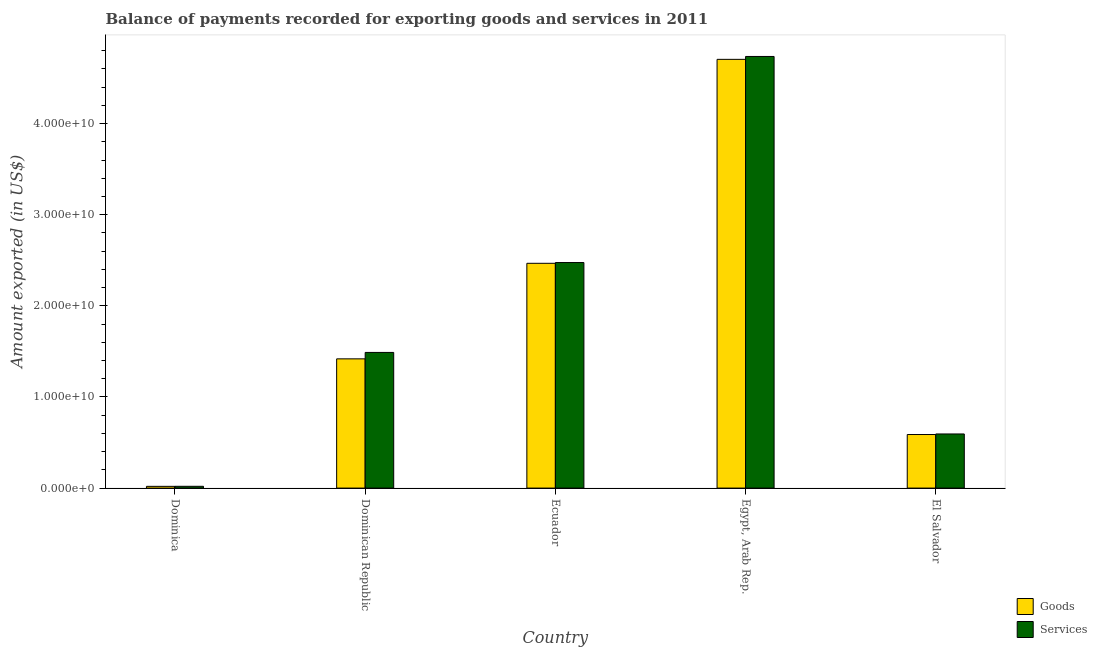How many different coloured bars are there?
Your answer should be very brief. 2. How many groups of bars are there?
Provide a short and direct response. 5. Are the number of bars on each tick of the X-axis equal?
Keep it short and to the point. Yes. What is the label of the 2nd group of bars from the left?
Your answer should be compact. Dominican Republic. In how many cases, is the number of bars for a given country not equal to the number of legend labels?
Make the answer very short. 0. What is the amount of goods exported in Egypt, Arab Rep.?
Your answer should be very brief. 4.71e+1. Across all countries, what is the maximum amount of services exported?
Give a very brief answer. 4.74e+1. Across all countries, what is the minimum amount of goods exported?
Make the answer very short. 1.91e+08. In which country was the amount of goods exported maximum?
Ensure brevity in your answer.  Egypt, Arab Rep. In which country was the amount of goods exported minimum?
Give a very brief answer. Dominica. What is the total amount of services exported in the graph?
Offer a very short reply. 9.32e+1. What is the difference between the amount of services exported in Dominica and that in Dominican Republic?
Keep it short and to the point. -1.47e+1. What is the difference between the amount of services exported in Ecuador and the amount of goods exported in Dominican Republic?
Ensure brevity in your answer.  1.06e+1. What is the average amount of services exported per country?
Your answer should be very brief. 1.86e+1. What is the difference between the amount of services exported and amount of goods exported in Dominica?
Your answer should be very brief. 4.93e+06. In how many countries, is the amount of goods exported greater than 12000000000 US$?
Provide a short and direct response. 3. What is the ratio of the amount of goods exported in Dominican Republic to that in Ecuador?
Your answer should be compact. 0.57. Is the difference between the amount of goods exported in Dominican Republic and Egypt, Arab Rep. greater than the difference between the amount of services exported in Dominican Republic and Egypt, Arab Rep.?
Your answer should be very brief. No. What is the difference between the highest and the second highest amount of goods exported?
Provide a short and direct response. 2.24e+1. What is the difference between the highest and the lowest amount of goods exported?
Offer a very short reply. 4.69e+1. In how many countries, is the amount of goods exported greater than the average amount of goods exported taken over all countries?
Provide a short and direct response. 2. Is the sum of the amount of services exported in Ecuador and Egypt, Arab Rep. greater than the maximum amount of goods exported across all countries?
Give a very brief answer. Yes. What does the 1st bar from the left in Dominican Republic represents?
Offer a terse response. Goods. What does the 2nd bar from the right in Dominica represents?
Your answer should be very brief. Goods. How many countries are there in the graph?
Your answer should be compact. 5. What is the difference between two consecutive major ticks on the Y-axis?
Provide a short and direct response. 1.00e+1. Does the graph contain any zero values?
Provide a short and direct response. No. What is the title of the graph?
Give a very brief answer. Balance of payments recorded for exporting goods and services in 2011. What is the label or title of the X-axis?
Make the answer very short. Country. What is the label or title of the Y-axis?
Provide a short and direct response. Amount exported (in US$). What is the Amount exported (in US$) in Goods in Dominica?
Your response must be concise. 1.91e+08. What is the Amount exported (in US$) of Services in Dominica?
Your answer should be very brief. 1.96e+08. What is the Amount exported (in US$) in Goods in Dominican Republic?
Give a very brief answer. 1.42e+1. What is the Amount exported (in US$) of Services in Dominican Republic?
Make the answer very short. 1.49e+1. What is the Amount exported (in US$) of Goods in Ecuador?
Your answer should be compact. 2.47e+1. What is the Amount exported (in US$) of Services in Ecuador?
Give a very brief answer. 2.48e+1. What is the Amount exported (in US$) of Goods in Egypt, Arab Rep.?
Your answer should be compact. 4.71e+1. What is the Amount exported (in US$) of Services in Egypt, Arab Rep.?
Your answer should be compact. 4.74e+1. What is the Amount exported (in US$) in Goods in El Salvador?
Provide a short and direct response. 5.88e+09. What is the Amount exported (in US$) in Services in El Salvador?
Provide a short and direct response. 5.94e+09. Across all countries, what is the maximum Amount exported (in US$) in Goods?
Your answer should be very brief. 4.71e+1. Across all countries, what is the maximum Amount exported (in US$) in Services?
Give a very brief answer. 4.74e+1. Across all countries, what is the minimum Amount exported (in US$) of Goods?
Make the answer very short. 1.91e+08. Across all countries, what is the minimum Amount exported (in US$) of Services?
Ensure brevity in your answer.  1.96e+08. What is the total Amount exported (in US$) of Goods in the graph?
Make the answer very short. 9.20e+1. What is the total Amount exported (in US$) of Services in the graph?
Offer a terse response. 9.32e+1. What is the difference between the Amount exported (in US$) of Goods in Dominica and that in Dominican Republic?
Provide a succinct answer. -1.40e+1. What is the difference between the Amount exported (in US$) in Services in Dominica and that in Dominican Republic?
Give a very brief answer. -1.47e+1. What is the difference between the Amount exported (in US$) in Goods in Dominica and that in Ecuador?
Your answer should be compact. -2.45e+1. What is the difference between the Amount exported (in US$) of Services in Dominica and that in Ecuador?
Ensure brevity in your answer.  -2.46e+1. What is the difference between the Amount exported (in US$) in Goods in Dominica and that in Egypt, Arab Rep.?
Provide a short and direct response. -4.69e+1. What is the difference between the Amount exported (in US$) of Services in Dominica and that in Egypt, Arab Rep.?
Ensure brevity in your answer.  -4.72e+1. What is the difference between the Amount exported (in US$) of Goods in Dominica and that in El Salvador?
Offer a very short reply. -5.69e+09. What is the difference between the Amount exported (in US$) of Services in Dominica and that in El Salvador?
Provide a short and direct response. -5.74e+09. What is the difference between the Amount exported (in US$) in Goods in Dominican Republic and that in Ecuador?
Your response must be concise. -1.05e+1. What is the difference between the Amount exported (in US$) of Services in Dominican Republic and that in Ecuador?
Your answer should be very brief. -9.87e+09. What is the difference between the Amount exported (in US$) in Goods in Dominican Republic and that in Egypt, Arab Rep.?
Your answer should be very brief. -3.29e+1. What is the difference between the Amount exported (in US$) in Services in Dominican Republic and that in Egypt, Arab Rep.?
Make the answer very short. -3.25e+1. What is the difference between the Amount exported (in US$) in Goods in Dominican Republic and that in El Salvador?
Your answer should be compact. 8.31e+09. What is the difference between the Amount exported (in US$) of Services in Dominican Republic and that in El Salvador?
Your response must be concise. 8.95e+09. What is the difference between the Amount exported (in US$) of Goods in Ecuador and that in Egypt, Arab Rep.?
Provide a succinct answer. -2.24e+1. What is the difference between the Amount exported (in US$) of Services in Ecuador and that in Egypt, Arab Rep.?
Your answer should be compact. -2.26e+1. What is the difference between the Amount exported (in US$) of Goods in Ecuador and that in El Salvador?
Give a very brief answer. 1.88e+1. What is the difference between the Amount exported (in US$) in Services in Ecuador and that in El Salvador?
Your response must be concise. 1.88e+1. What is the difference between the Amount exported (in US$) in Goods in Egypt, Arab Rep. and that in El Salvador?
Offer a very short reply. 4.12e+1. What is the difference between the Amount exported (in US$) in Services in Egypt, Arab Rep. and that in El Salvador?
Ensure brevity in your answer.  4.14e+1. What is the difference between the Amount exported (in US$) of Goods in Dominica and the Amount exported (in US$) of Services in Dominican Republic?
Your answer should be very brief. -1.47e+1. What is the difference between the Amount exported (in US$) in Goods in Dominica and the Amount exported (in US$) in Services in Ecuador?
Your response must be concise. -2.46e+1. What is the difference between the Amount exported (in US$) of Goods in Dominica and the Amount exported (in US$) of Services in Egypt, Arab Rep.?
Your answer should be compact. -4.72e+1. What is the difference between the Amount exported (in US$) of Goods in Dominica and the Amount exported (in US$) of Services in El Salvador?
Make the answer very short. -5.75e+09. What is the difference between the Amount exported (in US$) of Goods in Dominican Republic and the Amount exported (in US$) of Services in Ecuador?
Provide a succinct answer. -1.06e+1. What is the difference between the Amount exported (in US$) in Goods in Dominican Republic and the Amount exported (in US$) in Services in Egypt, Arab Rep.?
Make the answer very short. -3.32e+1. What is the difference between the Amount exported (in US$) of Goods in Dominican Republic and the Amount exported (in US$) of Services in El Salvador?
Ensure brevity in your answer.  8.24e+09. What is the difference between the Amount exported (in US$) of Goods in Ecuador and the Amount exported (in US$) of Services in Egypt, Arab Rep.?
Keep it short and to the point. -2.27e+1. What is the difference between the Amount exported (in US$) in Goods in Ecuador and the Amount exported (in US$) in Services in El Salvador?
Offer a terse response. 1.87e+1. What is the difference between the Amount exported (in US$) in Goods in Egypt, Arab Rep. and the Amount exported (in US$) in Services in El Salvador?
Ensure brevity in your answer.  4.11e+1. What is the average Amount exported (in US$) of Goods per country?
Make the answer very short. 1.84e+1. What is the average Amount exported (in US$) of Services per country?
Offer a terse response. 1.86e+1. What is the difference between the Amount exported (in US$) in Goods and Amount exported (in US$) in Services in Dominica?
Make the answer very short. -4.93e+06. What is the difference between the Amount exported (in US$) in Goods and Amount exported (in US$) in Services in Dominican Republic?
Ensure brevity in your answer.  -7.05e+08. What is the difference between the Amount exported (in US$) in Goods and Amount exported (in US$) in Services in Ecuador?
Your answer should be compact. -8.45e+07. What is the difference between the Amount exported (in US$) of Goods and Amount exported (in US$) of Services in Egypt, Arab Rep.?
Your response must be concise. -3.18e+08. What is the difference between the Amount exported (in US$) of Goods and Amount exported (in US$) of Services in El Salvador?
Your answer should be compact. -6.17e+07. What is the ratio of the Amount exported (in US$) in Goods in Dominica to that in Dominican Republic?
Provide a short and direct response. 0.01. What is the ratio of the Amount exported (in US$) of Services in Dominica to that in Dominican Republic?
Provide a short and direct response. 0.01. What is the ratio of the Amount exported (in US$) in Goods in Dominica to that in Ecuador?
Provide a short and direct response. 0.01. What is the ratio of the Amount exported (in US$) in Services in Dominica to that in Ecuador?
Your answer should be compact. 0.01. What is the ratio of the Amount exported (in US$) of Goods in Dominica to that in Egypt, Arab Rep.?
Offer a very short reply. 0. What is the ratio of the Amount exported (in US$) in Services in Dominica to that in Egypt, Arab Rep.?
Offer a very short reply. 0. What is the ratio of the Amount exported (in US$) in Goods in Dominica to that in El Salvador?
Offer a very short reply. 0.03. What is the ratio of the Amount exported (in US$) of Services in Dominica to that in El Salvador?
Offer a very short reply. 0.03. What is the ratio of the Amount exported (in US$) in Goods in Dominican Republic to that in Ecuador?
Keep it short and to the point. 0.57. What is the ratio of the Amount exported (in US$) of Services in Dominican Republic to that in Ecuador?
Offer a very short reply. 0.6. What is the ratio of the Amount exported (in US$) in Goods in Dominican Republic to that in Egypt, Arab Rep.?
Provide a succinct answer. 0.3. What is the ratio of the Amount exported (in US$) in Services in Dominican Republic to that in Egypt, Arab Rep.?
Your response must be concise. 0.31. What is the ratio of the Amount exported (in US$) in Goods in Dominican Republic to that in El Salvador?
Give a very brief answer. 2.41. What is the ratio of the Amount exported (in US$) of Services in Dominican Republic to that in El Salvador?
Give a very brief answer. 2.51. What is the ratio of the Amount exported (in US$) of Goods in Ecuador to that in Egypt, Arab Rep.?
Provide a short and direct response. 0.52. What is the ratio of the Amount exported (in US$) in Services in Ecuador to that in Egypt, Arab Rep.?
Your response must be concise. 0.52. What is the ratio of the Amount exported (in US$) in Goods in Ecuador to that in El Salvador?
Your answer should be very brief. 4.2. What is the ratio of the Amount exported (in US$) of Services in Ecuador to that in El Salvador?
Provide a succinct answer. 4.17. What is the ratio of the Amount exported (in US$) in Goods in Egypt, Arab Rep. to that in El Salvador?
Provide a succinct answer. 8. What is the ratio of the Amount exported (in US$) of Services in Egypt, Arab Rep. to that in El Salvador?
Offer a terse response. 7.97. What is the difference between the highest and the second highest Amount exported (in US$) of Goods?
Ensure brevity in your answer.  2.24e+1. What is the difference between the highest and the second highest Amount exported (in US$) in Services?
Provide a short and direct response. 2.26e+1. What is the difference between the highest and the lowest Amount exported (in US$) in Goods?
Provide a short and direct response. 4.69e+1. What is the difference between the highest and the lowest Amount exported (in US$) of Services?
Provide a short and direct response. 4.72e+1. 